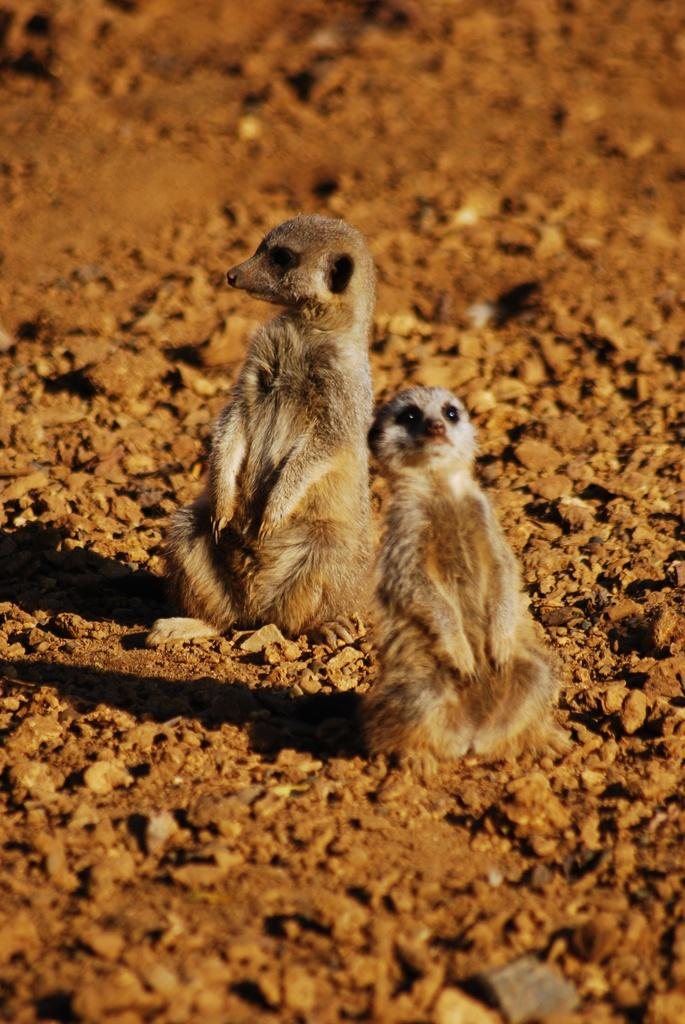How many meerkats are present in the image? There are two meerkats in the image. What else can be observed in the image besides the meerkats? Shadows are visible in the image. What type of company do the meerkats work for in the image? The image does not depict the meerkats working for a company, nor is there any indication of a company in the image. 